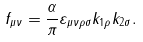Convert formula to latex. <formula><loc_0><loc_0><loc_500><loc_500>f _ { \mu \nu } = \frac { \alpha } { \pi } \varepsilon _ { \mu \nu \rho \sigma } k _ { 1 \rho } k _ { 2 \sigma } .</formula> 